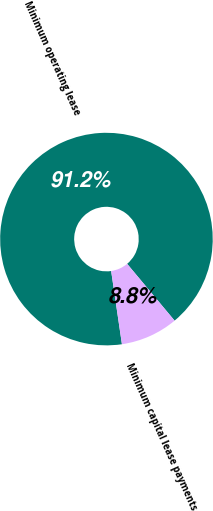Convert chart. <chart><loc_0><loc_0><loc_500><loc_500><pie_chart><fcel>Minimum operating lease<fcel>Minimum capital lease payments<nl><fcel>91.25%<fcel>8.75%<nl></chart> 